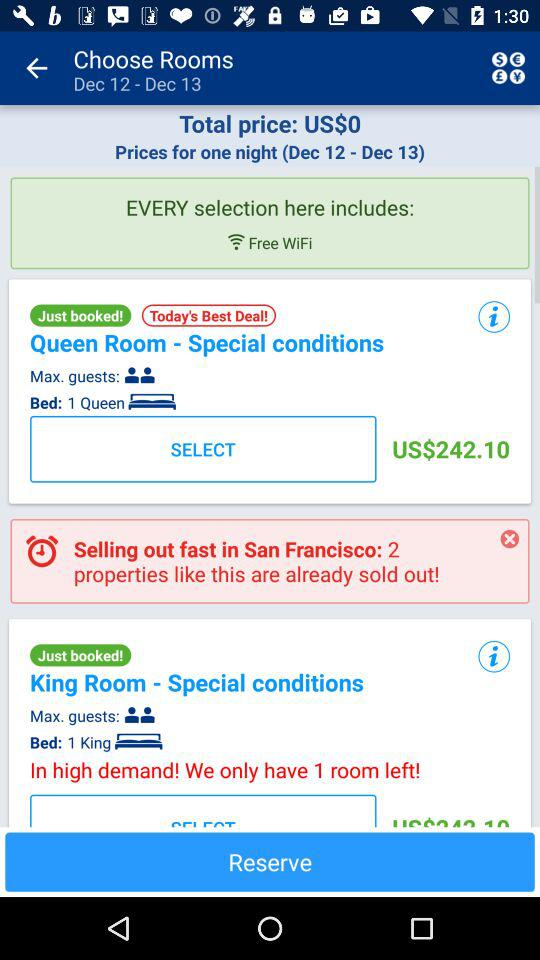How many king rooms are left? There is 1 king room left. 